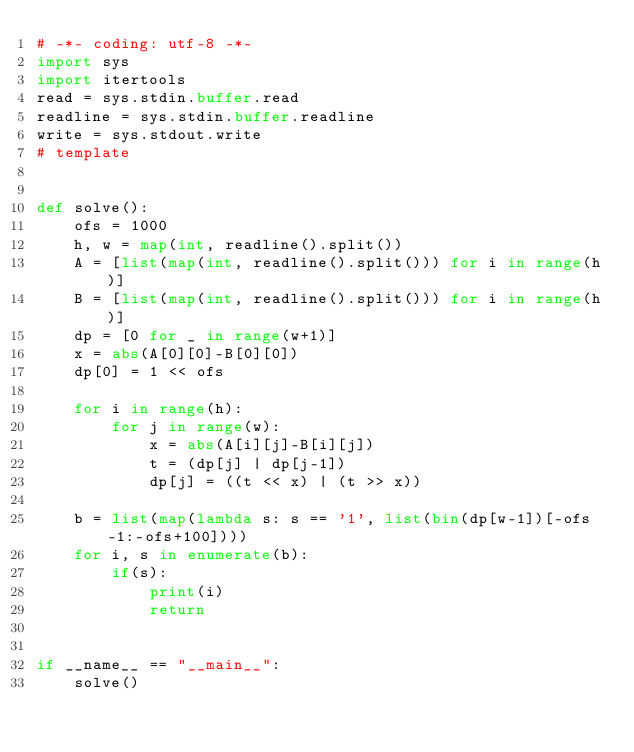Convert code to text. <code><loc_0><loc_0><loc_500><loc_500><_Python_># -*- coding: utf-8 -*-
import sys
import itertools
read = sys.stdin.buffer.read
readline = sys.stdin.buffer.readline
write = sys.stdout.write
# template


def solve():
    ofs = 1000
    h, w = map(int, readline().split())
    A = [list(map(int, readline().split())) for i in range(h)]
    B = [list(map(int, readline().split())) for i in range(h)]
    dp = [0 for _ in range(w+1)]
    x = abs(A[0][0]-B[0][0])
    dp[0] = 1 << ofs

    for i in range(h):
        for j in range(w):
            x = abs(A[i][j]-B[i][j])
            t = (dp[j] | dp[j-1])
            dp[j] = ((t << x) | (t >> x))

    b = list(map(lambda s: s == '1', list(bin(dp[w-1])[-ofs-1:-ofs+100])))
    for i, s in enumerate(b):
        if(s):
            print(i)
            return


if __name__ == "__main__":
    solve()
</code> 